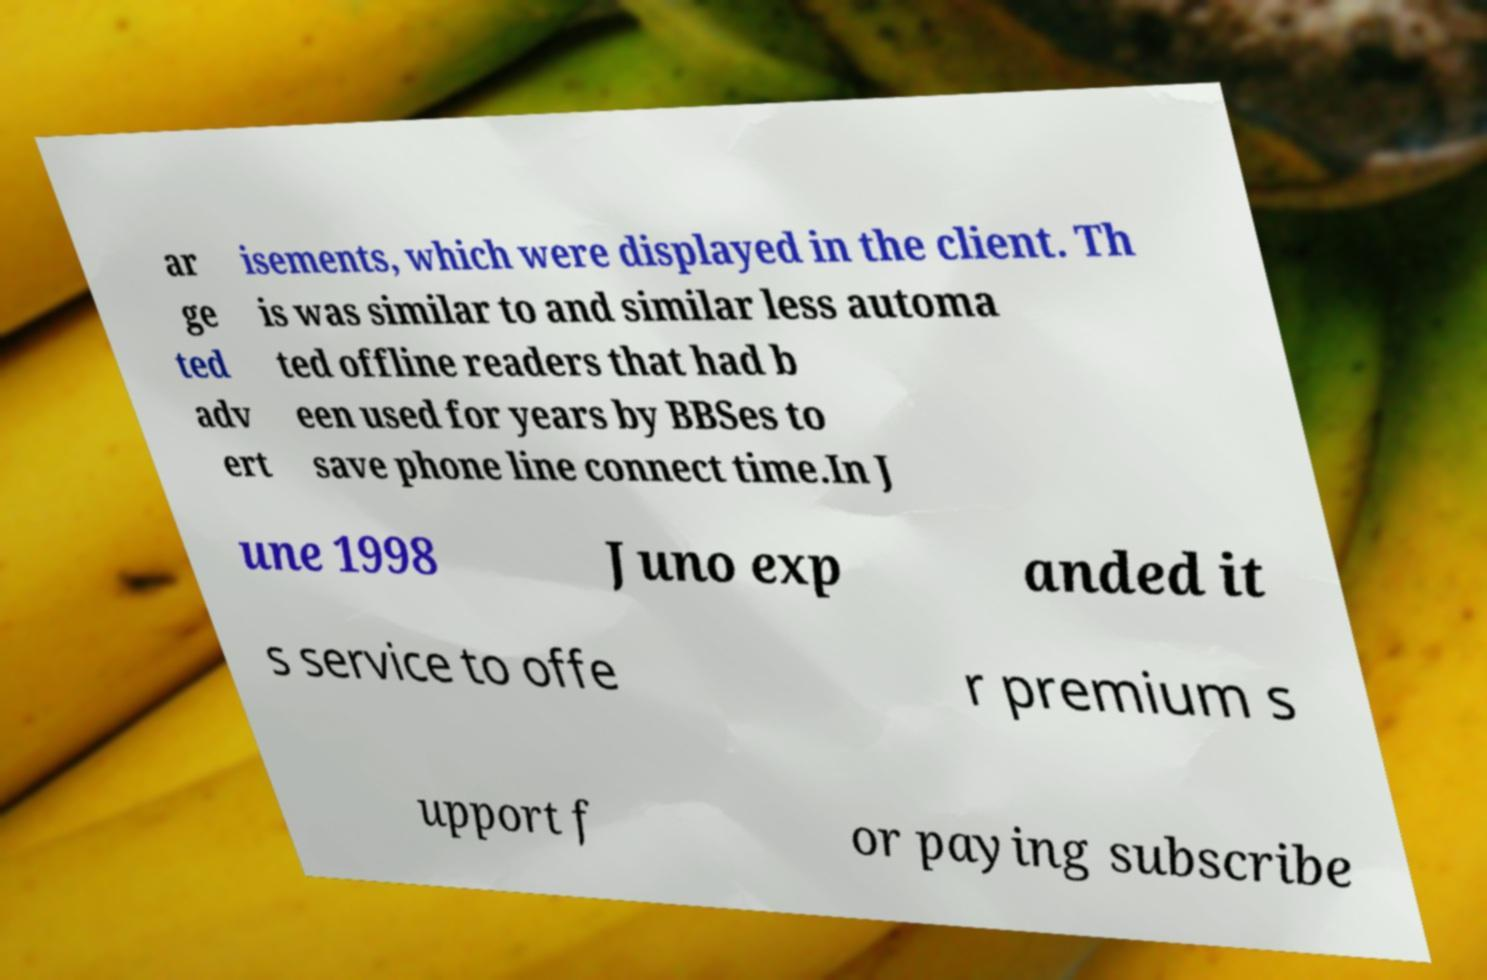Please read and relay the text visible in this image. What does it say? ar ge ted adv ert isements, which were displayed in the client. Th is was similar to and similar less automa ted offline readers that had b een used for years by BBSes to save phone line connect time.In J une 1998 Juno exp anded it s service to offe r premium s upport f or paying subscribe 